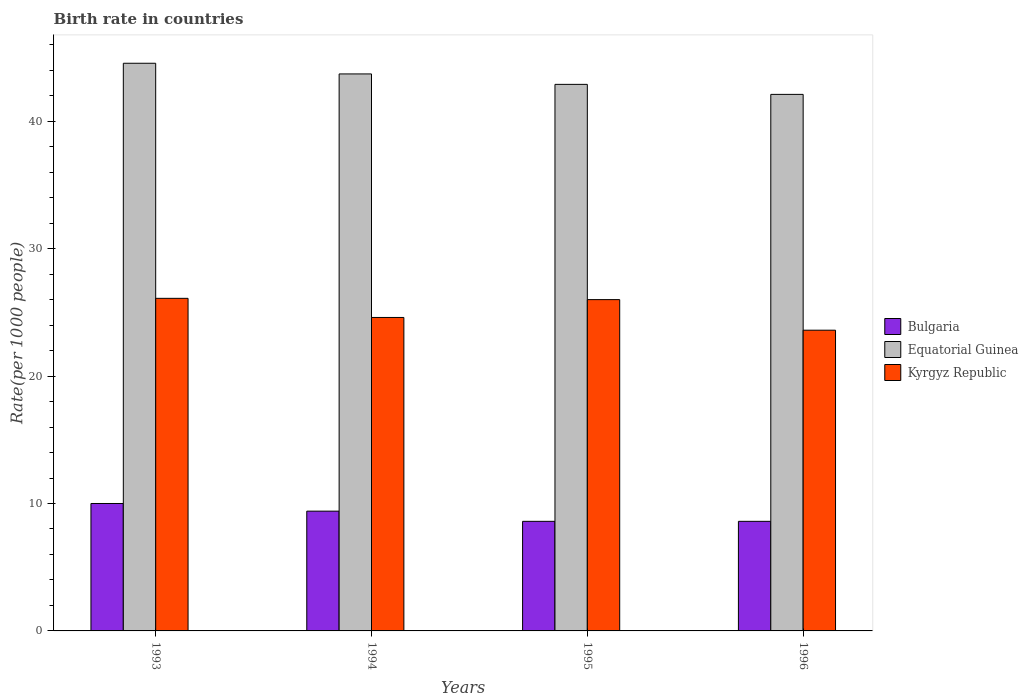How many different coloured bars are there?
Your answer should be compact. 3. How many groups of bars are there?
Make the answer very short. 4. How many bars are there on the 4th tick from the left?
Your answer should be very brief. 3. How many bars are there on the 1st tick from the right?
Make the answer very short. 3. What is the birth rate in Bulgaria in 1996?
Offer a terse response. 8.6. Across all years, what is the minimum birth rate in Kyrgyz Republic?
Keep it short and to the point. 23.6. In which year was the birth rate in Kyrgyz Republic maximum?
Provide a short and direct response. 1993. In which year was the birth rate in Kyrgyz Republic minimum?
Your answer should be compact. 1996. What is the total birth rate in Equatorial Guinea in the graph?
Provide a succinct answer. 173.26. What is the difference between the birth rate in Bulgaria in 1995 and that in 1996?
Your answer should be very brief. 0. What is the difference between the birth rate in Kyrgyz Republic in 1996 and the birth rate in Bulgaria in 1995?
Keep it short and to the point. 15. What is the average birth rate in Kyrgyz Republic per year?
Your answer should be compact. 25.08. In the year 1994, what is the difference between the birth rate in Bulgaria and birth rate in Kyrgyz Republic?
Ensure brevity in your answer.  -15.2. In how many years, is the birth rate in Equatorial Guinea greater than 24?
Provide a short and direct response. 4. What is the ratio of the birth rate in Kyrgyz Republic in 1994 to that in 1996?
Make the answer very short. 1.04. Is the birth rate in Equatorial Guinea in 1995 less than that in 1996?
Your answer should be compact. No. What is the difference between the highest and the second highest birth rate in Kyrgyz Republic?
Offer a terse response. 0.1. What is the difference between the highest and the lowest birth rate in Bulgaria?
Keep it short and to the point. 1.4. In how many years, is the birth rate in Kyrgyz Republic greater than the average birth rate in Kyrgyz Republic taken over all years?
Your answer should be very brief. 2. Are all the bars in the graph horizontal?
Offer a very short reply. No. How many years are there in the graph?
Make the answer very short. 4. Are the values on the major ticks of Y-axis written in scientific E-notation?
Keep it short and to the point. No. Does the graph contain any zero values?
Your answer should be very brief. No. What is the title of the graph?
Your answer should be compact. Birth rate in countries. Does "Bermuda" appear as one of the legend labels in the graph?
Provide a succinct answer. No. What is the label or title of the Y-axis?
Your answer should be compact. Rate(per 1000 people). What is the Rate(per 1000 people) in Equatorial Guinea in 1993?
Provide a short and direct response. 44.55. What is the Rate(per 1000 people) in Kyrgyz Republic in 1993?
Your answer should be compact. 26.1. What is the Rate(per 1000 people) of Bulgaria in 1994?
Your response must be concise. 9.4. What is the Rate(per 1000 people) in Equatorial Guinea in 1994?
Offer a terse response. 43.71. What is the Rate(per 1000 people) in Kyrgyz Republic in 1994?
Make the answer very short. 24.6. What is the Rate(per 1000 people) of Equatorial Guinea in 1995?
Provide a short and direct response. 42.89. What is the Rate(per 1000 people) of Bulgaria in 1996?
Provide a short and direct response. 8.6. What is the Rate(per 1000 people) of Equatorial Guinea in 1996?
Your answer should be very brief. 42.11. What is the Rate(per 1000 people) of Kyrgyz Republic in 1996?
Give a very brief answer. 23.6. Across all years, what is the maximum Rate(per 1000 people) of Equatorial Guinea?
Your answer should be compact. 44.55. Across all years, what is the maximum Rate(per 1000 people) of Kyrgyz Republic?
Offer a very short reply. 26.1. Across all years, what is the minimum Rate(per 1000 people) of Bulgaria?
Provide a short and direct response. 8.6. Across all years, what is the minimum Rate(per 1000 people) in Equatorial Guinea?
Offer a terse response. 42.11. Across all years, what is the minimum Rate(per 1000 people) in Kyrgyz Republic?
Offer a terse response. 23.6. What is the total Rate(per 1000 people) in Bulgaria in the graph?
Provide a succinct answer. 36.6. What is the total Rate(per 1000 people) in Equatorial Guinea in the graph?
Give a very brief answer. 173.26. What is the total Rate(per 1000 people) of Kyrgyz Republic in the graph?
Provide a succinct answer. 100.3. What is the difference between the Rate(per 1000 people) in Bulgaria in 1993 and that in 1994?
Your answer should be compact. 0.6. What is the difference between the Rate(per 1000 people) of Equatorial Guinea in 1993 and that in 1994?
Your answer should be compact. 0.84. What is the difference between the Rate(per 1000 people) of Kyrgyz Republic in 1993 and that in 1994?
Give a very brief answer. 1.5. What is the difference between the Rate(per 1000 people) in Bulgaria in 1993 and that in 1995?
Offer a very short reply. 1.4. What is the difference between the Rate(per 1000 people) of Equatorial Guinea in 1993 and that in 1995?
Offer a very short reply. 1.66. What is the difference between the Rate(per 1000 people) in Kyrgyz Republic in 1993 and that in 1995?
Your response must be concise. 0.1. What is the difference between the Rate(per 1000 people) in Equatorial Guinea in 1993 and that in 1996?
Make the answer very short. 2.44. What is the difference between the Rate(per 1000 people) in Kyrgyz Republic in 1993 and that in 1996?
Your answer should be compact. 2.5. What is the difference between the Rate(per 1000 people) in Bulgaria in 1994 and that in 1995?
Your response must be concise. 0.8. What is the difference between the Rate(per 1000 people) of Equatorial Guinea in 1994 and that in 1995?
Keep it short and to the point. 0.82. What is the difference between the Rate(per 1000 people) of Kyrgyz Republic in 1994 and that in 1995?
Provide a short and direct response. -1.4. What is the difference between the Rate(per 1000 people) in Bulgaria in 1994 and that in 1996?
Provide a succinct answer. 0.8. What is the difference between the Rate(per 1000 people) of Equatorial Guinea in 1994 and that in 1996?
Provide a short and direct response. 1.61. What is the difference between the Rate(per 1000 people) of Equatorial Guinea in 1995 and that in 1996?
Keep it short and to the point. 0.79. What is the difference between the Rate(per 1000 people) of Bulgaria in 1993 and the Rate(per 1000 people) of Equatorial Guinea in 1994?
Ensure brevity in your answer.  -33.71. What is the difference between the Rate(per 1000 people) of Bulgaria in 1993 and the Rate(per 1000 people) of Kyrgyz Republic in 1994?
Your response must be concise. -14.6. What is the difference between the Rate(per 1000 people) in Equatorial Guinea in 1993 and the Rate(per 1000 people) in Kyrgyz Republic in 1994?
Your answer should be compact. 19.95. What is the difference between the Rate(per 1000 people) in Bulgaria in 1993 and the Rate(per 1000 people) in Equatorial Guinea in 1995?
Offer a very short reply. -32.89. What is the difference between the Rate(per 1000 people) of Bulgaria in 1993 and the Rate(per 1000 people) of Kyrgyz Republic in 1995?
Your response must be concise. -16. What is the difference between the Rate(per 1000 people) in Equatorial Guinea in 1993 and the Rate(per 1000 people) in Kyrgyz Republic in 1995?
Your answer should be very brief. 18.55. What is the difference between the Rate(per 1000 people) of Bulgaria in 1993 and the Rate(per 1000 people) of Equatorial Guinea in 1996?
Provide a short and direct response. -32.11. What is the difference between the Rate(per 1000 people) of Bulgaria in 1993 and the Rate(per 1000 people) of Kyrgyz Republic in 1996?
Ensure brevity in your answer.  -13.6. What is the difference between the Rate(per 1000 people) of Equatorial Guinea in 1993 and the Rate(per 1000 people) of Kyrgyz Republic in 1996?
Your answer should be compact. 20.95. What is the difference between the Rate(per 1000 people) in Bulgaria in 1994 and the Rate(per 1000 people) in Equatorial Guinea in 1995?
Give a very brief answer. -33.49. What is the difference between the Rate(per 1000 people) of Bulgaria in 1994 and the Rate(per 1000 people) of Kyrgyz Republic in 1995?
Ensure brevity in your answer.  -16.6. What is the difference between the Rate(per 1000 people) of Equatorial Guinea in 1994 and the Rate(per 1000 people) of Kyrgyz Republic in 1995?
Your response must be concise. 17.71. What is the difference between the Rate(per 1000 people) in Bulgaria in 1994 and the Rate(per 1000 people) in Equatorial Guinea in 1996?
Ensure brevity in your answer.  -32.71. What is the difference between the Rate(per 1000 people) of Equatorial Guinea in 1994 and the Rate(per 1000 people) of Kyrgyz Republic in 1996?
Keep it short and to the point. 20.11. What is the difference between the Rate(per 1000 people) of Bulgaria in 1995 and the Rate(per 1000 people) of Equatorial Guinea in 1996?
Make the answer very short. -33.51. What is the difference between the Rate(per 1000 people) in Bulgaria in 1995 and the Rate(per 1000 people) in Kyrgyz Republic in 1996?
Your response must be concise. -15. What is the difference between the Rate(per 1000 people) of Equatorial Guinea in 1995 and the Rate(per 1000 people) of Kyrgyz Republic in 1996?
Offer a very short reply. 19.29. What is the average Rate(per 1000 people) in Bulgaria per year?
Offer a very short reply. 9.15. What is the average Rate(per 1000 people) in Equatorial Guinea per year?
Your response must be concise. 43.31. What is the average Rate(per 1000 people) of Kyrgyz Republic per year?
Offer a very short reply. 25.07. In the year 1993, what is the difference between the Rate(per 1000 people) of Bulgaria and Rate(per 1000 people) of Equatorial Guinea?
Offer a very short reply. -34.55. In the year 1993, what is the difference between the Rate(per 1000 people) in Bulgaria and Rate(per 1000 people) in Kyrgyz Republic?
Offer a terse response. -16.1. In the year 1993, what is the difference between the Rate(per 1000 people) in Equatorial Guinea and Rate(per 1000 people) in Kyrgyz Republic?
Offer a terse response. 18.45. In the year 1994, what is the difference between the Rate(per 1000 people) in Bulgaria and Rate(per 1000 people) in Equatorial Guinea?
Make the answer very short. -34.31. In the year 1994, what is the difference between the Rate(per 1000 people) of Bulgaria and Rate(per 1000 people) of Kyrgyz Republic?
Provide a short and direct response. -15.2. In the year 1994, what is the difference between the Rate(per 1000 people) in Equatorial Guinea and Rate(per 1000 people) in Kyrgyz Republic?
Offer a terse response. 19.11. In the year 1995, what is the difference between the Rate(per 1000 people) in Bulgaria and Rate(per 1000 people) in Equatorial Guinea?
Keep it short and to the point. -34.29. In the year 1995, what is the difference between the Rate(per 1000 people) in Bulgaria and Rate(per 1000 people) in Kyrgyz Republic?
Give a very brief answer. -17.4. In the year 1995, what is the difference between the Rate(per 1000 people) of Equatorial Guinea and Rate(per 1000 people) of Kyrgyz Republic?
Offer a terse response. 16.89. In the year 1996, what is the difference between the Rate(per 1000 people) of Bulgaria and Rate(per 1000 people) of Equatorial Guinea?
Your answer should be compact. -33.51. In the year 1996, what is the difference between the Rate(per 1000 people) in Bulgaria and Rate(per 1000 people) in Kyrgyz Republic?
Provide a short and direct response. -15. In the year 1996, what is the difference between the Rate(per 1000 people) in Equatorial Guinea and Rate(per 1000 people) in Kyrgyz Republic?
Your answer should be very brief. 18.51. What is the ratio of the Rate(per 1000 people) in Bulgaria in 1993 to that in 1994?
Offer a terse response. 1.06. What is the ratio of the Rate(per 1000 people) in Equatorial Guinea in 1993 to that in 1994?
Ensure brevity in your answer.  1.02. What is the ratio of the Rate(per 1000 people) of Kyrgyz Republic in 1993 to that in 1994?
Keep it short and to the point. 1.06. What is the ratio of the Rate(per 1000 people) of Bulgaria in 1993 to that in 1995?
Keep it short and to the point. 1.16. What is the ratio of the Rate(per 1000 people) in Equatorial Guinea in 1993 to that in 1995?
Ensure brevity in your answer.  1.04. What is the ratio of the Rate(per 1000 people) in Bulgaria in 1993 to that in 1996?
Offer a very short reply. 1.16. What is the ratio of the Rate(per 1000 people) of Equatorial Guinea in 1993 to that in 1996?
Ensure brevity in your answer.  1.06. What is the ratio of the Rate(per 1000 people) in Kyrgyz Republic in 1993 to that in 1996?
Offer a very short reply. 1.11. What is the ratio of the Rate(per 1000 people) in Bulgaria in 1994 to that in 1995?
Provide a short and direct response. 1.09. What is the ratio of the Rate(per 1000 people) of Equatorial Guinea in 1994 to that in 1995?
Ensure brevity in your answer.  1.02. What is the ratio of the Rate(per 1000 people) in Kyrgyz Republic in 1994 to that in 1995?
Ensure brevity in your answer.  0.95. What is the ratio of the Rate(per 1000 people) in Bulgaria in 1994 to that in 1996?
Keep it short and to the point. 1.09. What is the ratio of the Rate(per 1000 people) of Equatorial Guinea in 1994 to that in 1996?
Offer a terse response. 1.04. What is the ratio of the Rate(per 1000 people) in Kyrgyz Republic in 1994 to that in 1996?
Your answer should be compact. 1.04. What is the ratio of the Rate(per 1000 people) in Bulgaria in 1995 to that in 1996?
Ensure brevity in your answer.  1. What is the ratio of the Rate(per 1000 people) in Equatorial Guinea in 1995 to that in 1996?
Keep it short and to the point. 1.02. What is the ratio of the Rate(per 1000 people) of Kyrgyz Republic in 1995 to that in 1996?
Your answer should be very brief. 1.1. What is the difference between the highest and the second highest Rate(per 1000 people) of Bulgaria?
Provide a short and direct response. 0.6. What is the difference between the highest and the second highest Rate(per 1000 people) of Equatorial Guinea?
Your answer should be compact. 0.84. What is the difference between the highest and the second highest Rate(per 1000 people) of Kyrgyz Republic?
Offer a very short reply. 0.1. What is the difference between the highest and the lowest Rate(per 1000 people) of Bulgaria?
Ensure brevity in your answer.  1.4. What is the difference between the highest and the lowest Rate(per 1000 people) in Equatorial Guinea?
Your response must be concise. 2.44. What is the difference between the highest and the lowest Rate(per 1000 people) in Kyrgyz Republic?
Offer a very short reply. 2.5. 